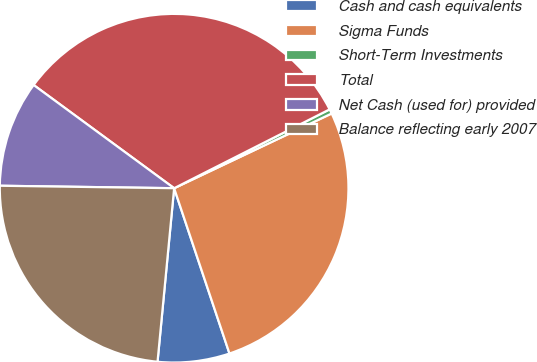Convert chart. <chart><loc_0><loc_0><loc_500><loc_500><pie_chart><fcel>Cash and cash equivalents<fcel>Sigma Funds<fcel>Short-Term Investments<fcel>Total<fcel>Net Cash (used for) provided<fcel>Balance reflecting early 2007<nl><fcel>6.66%<fcel>26.91%<fcel>0.42%<fcel>32.45%<fcel>9.86%<fcel>23.71%<nl></chart> 